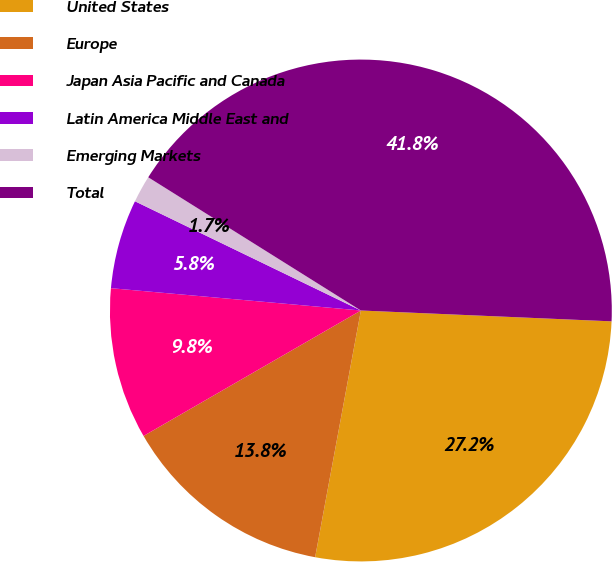<chart> <loc_0><loc_0><loc_500><loc_500><pie_chart><fcel>United States<fcel>Europe<fcel>Japan Asia Pacific and Canada<fcel>Latin America Middle East and<fcel>Emerging Markets<fcel>Total<nl><fcel>27.23%<fcel>13.75%<fcel>9.75%<fcel>5.75%<fcel>1.74%<fcel>41.78%<nl></chart> 